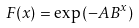Convert formula to latex. <formula><loc_0><loc_0><loc_500><loc_500>F ( x ) = \exp \left ( - A B ^ { x } \right )</formula> 